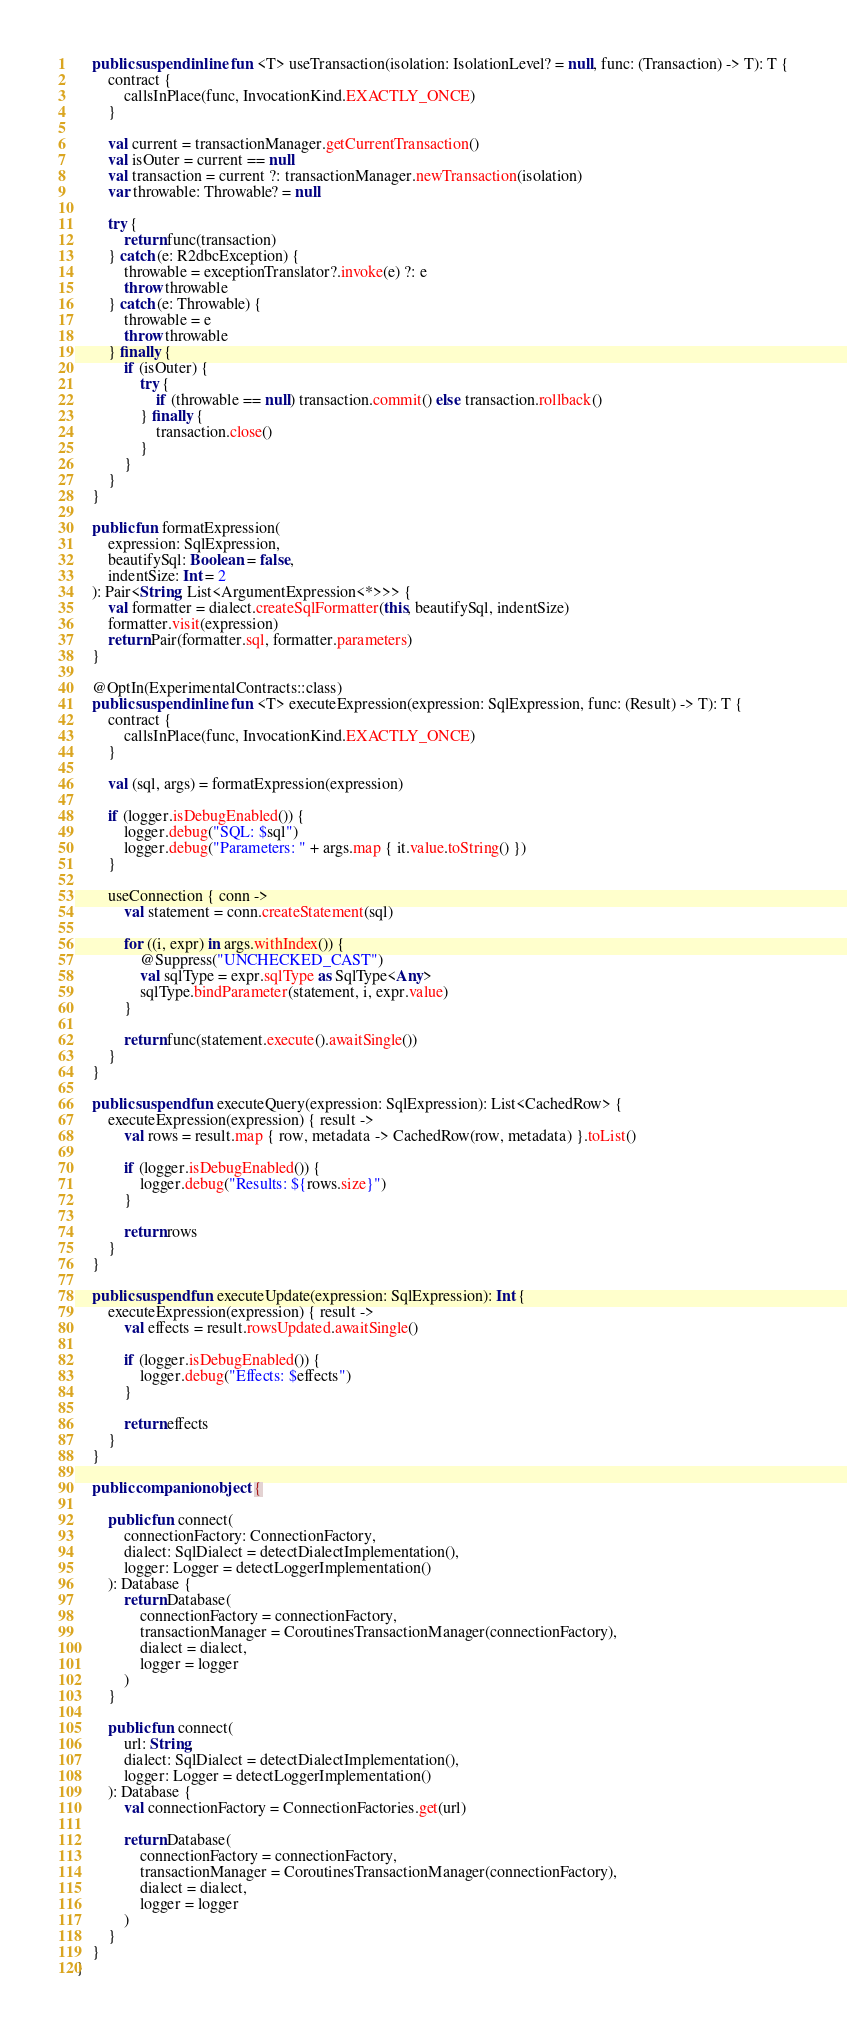<code> <loc_0><loc_0><loc_500><loc_500><_Kotlin_>    public suspend inline fun <T> useTransaction(isolation: IsolationLevel? = null, func: (Transaction) -> T): T {
        contract {
            callsInPlace(func, InvocationKind.EXACTLY_ONCE)
        }

        val current = transactionManager.getCurrentTransaction()
        val isOuter = current == null
        val transaction = current ?: transactionManager.newTransaction(isolation)
        var throwable: Throwable? = null

        try {
            return func(transaction)
        } catch (e: R2dbcException) {
            throwable = exceptionTranslator?.invoke(e) ?: e
            throw throwable
        } catch (e: Throwable) {
            throwable = e
            throw throwable
        } finally {
            if (isOuter) {
                try {
                    if (throwable == null) transaction.commit() else transaction.rollback()
                } finally {
                    transaction.close()
                }
            }
        }
    }

    public fun formatExpression(
        expression: SqlExpression,
        beautifySql: Boolean = false,
        indentSize: Int = 2
    ): Pair<String, List<ArgumentExpression<*>>> {
        val formatter = dialect.createSqlFormatter(this, beautifySql, indentSize)
        formatter.visit(expression)
        return Pair(formatter.sql, formatter.parameters)
    }

    @OptIn(ExperimentalContracts::class)
    public suspend inline fun <T> executeExpression(expression: SqlExpression, func: (Result) -> T): T {
        contract {
            callsInPlace(func, InvocationKind.EXACTLY_ONCE)
        }

        val (sql, args) = formatExpression(expression)

        if (logger.isDebugEnabled()) {
            logger.debug("SQL: $sql")
            logger.debug("Parameters: " + args.map { it.value.toString() })
        }

        useConnection { conn ->
            val statement = conn.createStatement(sql)

            for ((i, expr) in args.withIndex()) {
                @Suppress("UNCHECKED_CAST")
                val sqlType = expr.sqlType as SqlType<Any>
                sqlType.bindParameter(statement, i, expr.value)
            }

            return func(statement.execute().awaitSingle())
        }
    }

    public suspend fun executeQuery(expression: SqlExpression): List<CachedRow> {
        executeExpression(expression) { result ->
            val rows = result.map { row, metadata -> CachedRow(row, metadata) }.toList()

            if (logger.isDebugEnabled()) {
                logger.debug("Results: ${rows.size}")
            }

            return rows
        }
    }

    public suspend fun executeUpdate(expression: SqlExpression): Int {
        executeExpression(expression) { result ->
            val effects = result.rowsUpdated.awaitSingle()

            if (logger.isDebugEnabled()) {
                logger.debug("Effects: $effects")
            }

            return effects
        }
    }

    public companion object {

        public fun connect(
            connectionFactory: ConnectionFactory,
            dialect: SqlDialect = detectDialectImplementation(),
            logger: Logger = detectLoggerImplementation()
        ): Database {
            return Database(
                connectionFactory = connectionFactory,
                transactionManager = CoroutinesTransactionManager(connectionFactory),
                dialect = dialect,
                logger = logger
            )
        }

        public fun connect(
            url: String,
            dialect: SqlDialect = detectDialectImplementation(),
            logger: Logger = detectLoggerImplementation()
        ): Database {
            val connectionFactory = ConnectionFactories.get(url)

            return Database(
                connectionFactory = connectionFactory,
                transactionManager = CoroutinesTransactionManager(connectionFactory),
                dialect = dialect,
                logger = logger
            )
        }
    }
}</code> 